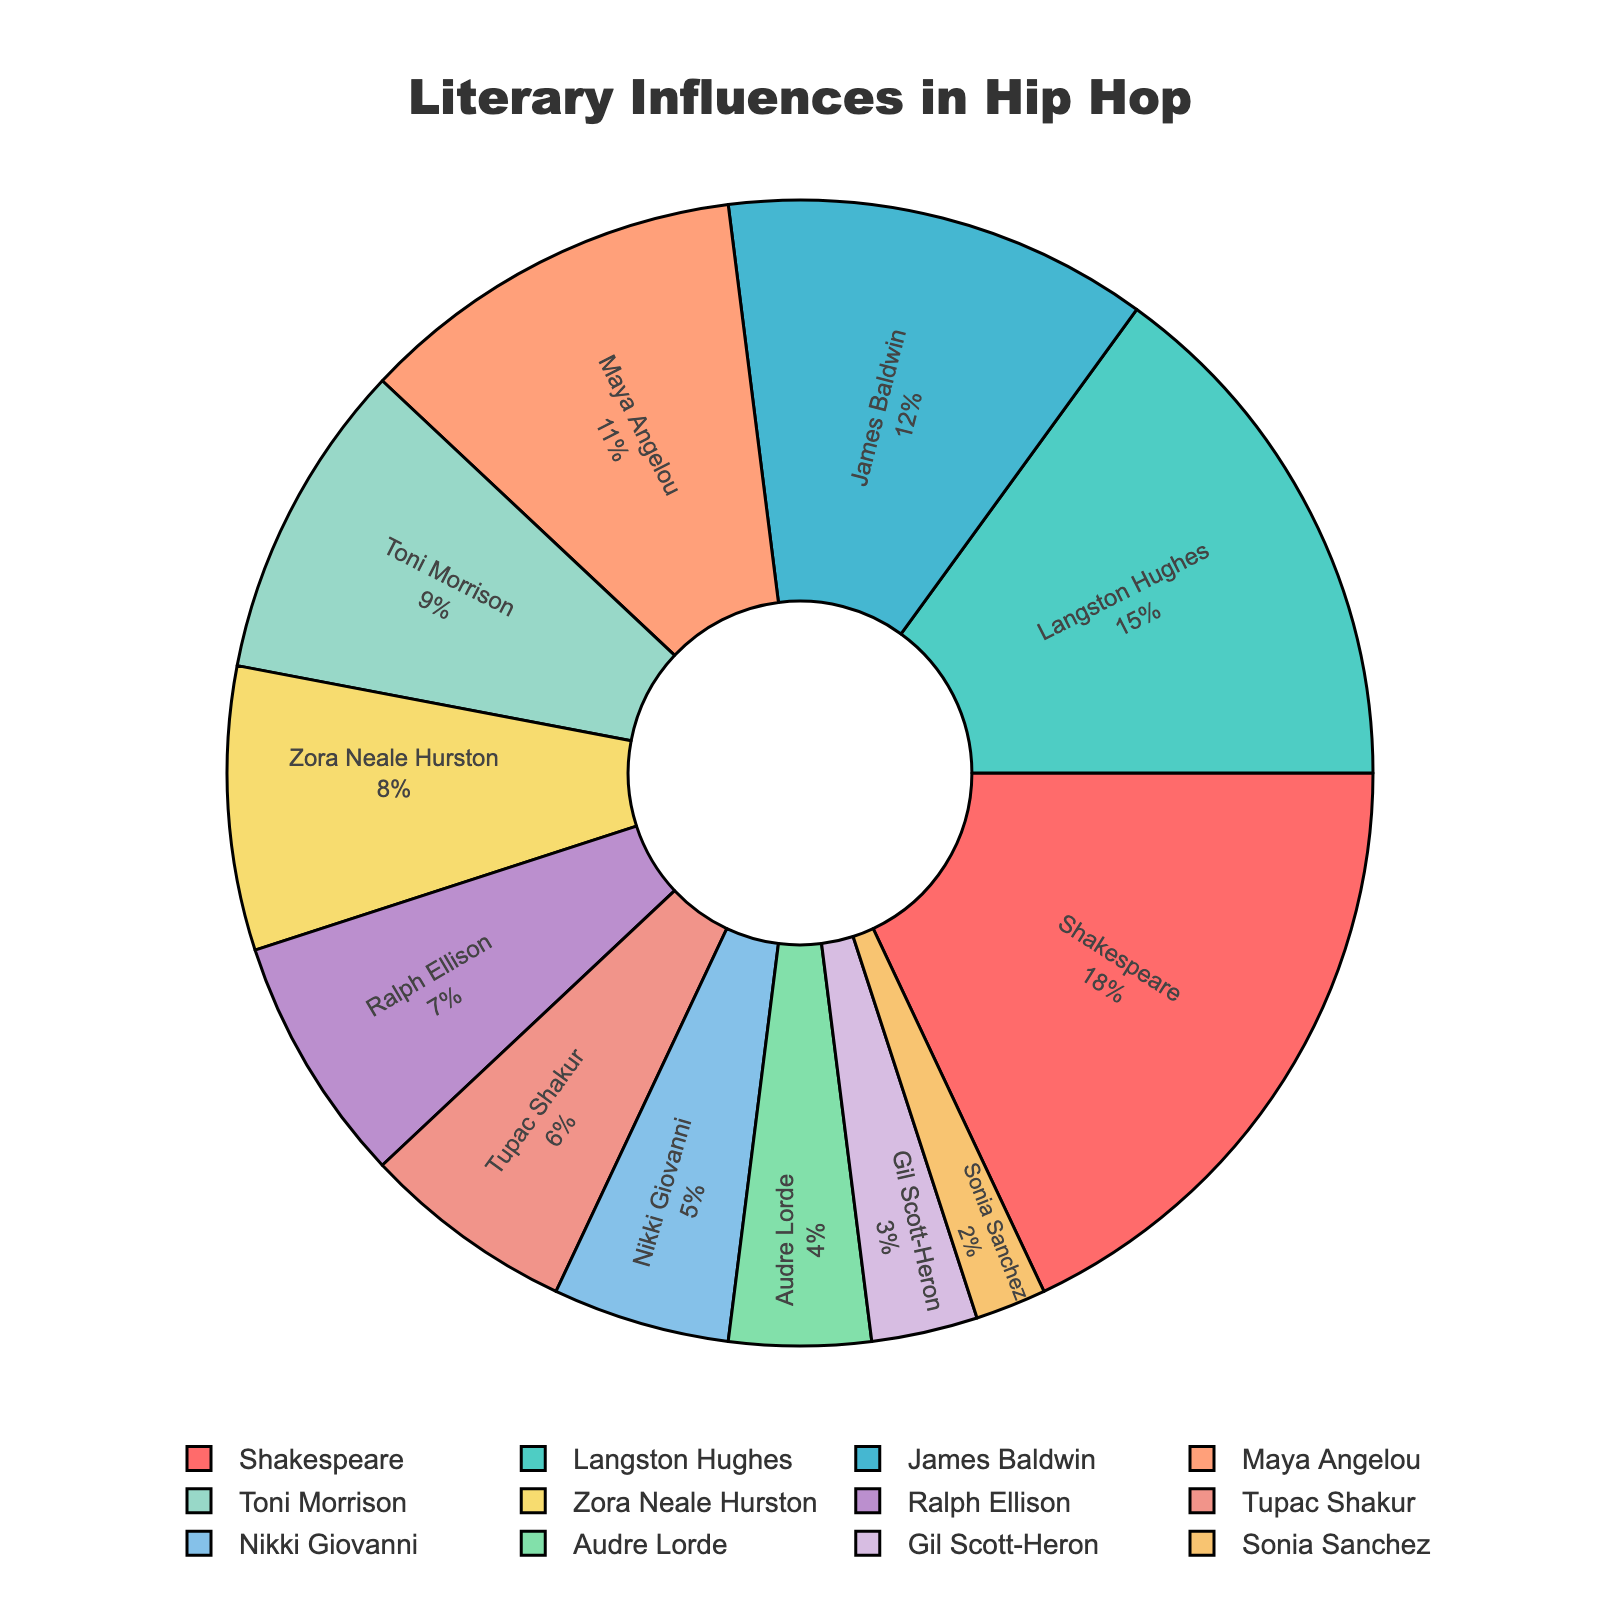Which literary influence has the highest percentage cited by popular hip hop artists? To determine the influence with the highest percentage, look for the slice of the pie chart that represents the largest proportion. The label inside this slice is "Shakespeare" with a percentage of 18%.
Answer: Shakespeare What is the combined percentage of Maya Angelou and James Baldwin? First, identify the percentages for Maya Angelou and James Baldwin from the pie chart, which are 11% and 12%, respectively. Add these percentages together: 11% + 12% = 23%.
Answer: 23% Which literary influences are tied for the lowest percentage, and what is that percentage? Look for the slices of the pie chart with the smallest proportions. The labels inside these slices are "Sonia Sanchez" and "Audre Lorde", both with the percentage of 2%.
Answer: Sonia Sanchez and Audre Lorde, 2% How much greater is the percentage of Shakespeare compared to Nikki Giovanni? Identify the percentages for Shakespeare and Nikki Giovanni from the pie chart, which are 18% and 5%, respectively. Subtract the smaller percentage from the larger percentage: 18% - 5% = 13%.
Answer: 13% What is the sum of the percentages for Zora Neale Hurston, Ralph Ellison, and Tupac Shakur? First, identify the percentages for Zora Neale Hurston, Ralph Ellison, and Tupac Shakur from the pie chart, which are 8%, 7%, and 6%, respectively. Add these percentages together: 8% + 7% + 6% = 21%.
Answer: 21% Which slice of the pie chart is colored red and which influence does it represent? Look at the pie chart and find the slice that is colored red. The label inside the red slice is "Shakespeare".
Answer: Shakespeare How do the combined percentages of Langston Hughes and Toni Morrison compare to Shakespeare? Identify the percentages for Langston Hughes, Toni Morrison, and Shakespeare from the pie chart, which are 15%, 9%, and 18%, respectively. Add the percentages for Langston Hughes and Toni Morrison: 15% + 9% = 24%. Compare this to the percentage for Shakespeare: 24% is greater than 18%.
Answer: 24% is greater than 18% What is the difference in percentage between Gil Scott-Heron and Langston Hughes? Identify the percentages for Gil Scott-Heron and Langston Hughes from the pie chart, which are 3% and 15%, respectively. Subtract the smaller percentage from the larger percentage: 15% - 3% = 12%.
Answer: 12% Who has a larger percentage, Toni Morrison or Maya Angelou, and by how much? Identify the percentages for Toni Morrison and Maya Angelou from the pie chart, which are 9% and 11%, respectively. Subtract the smaller percentage from the larger percentage: 11% - 9% = 2%. Maya Angelou has the larger percentage.
Answer: Maya Angelou by 2% What percentage of the total is represented by Gil Scott-Heron, Sonia Sanchez, and Audre Lorde combined? First, identify the percentages for Gil Scott-Heron, Sonia Sanchez, and Audre Lorde from the pie chart, which are 3%, 2%, and 4%, respectively. Add these percentages together: 3% + 2% + 4% = 9%.
Answer: 9% 